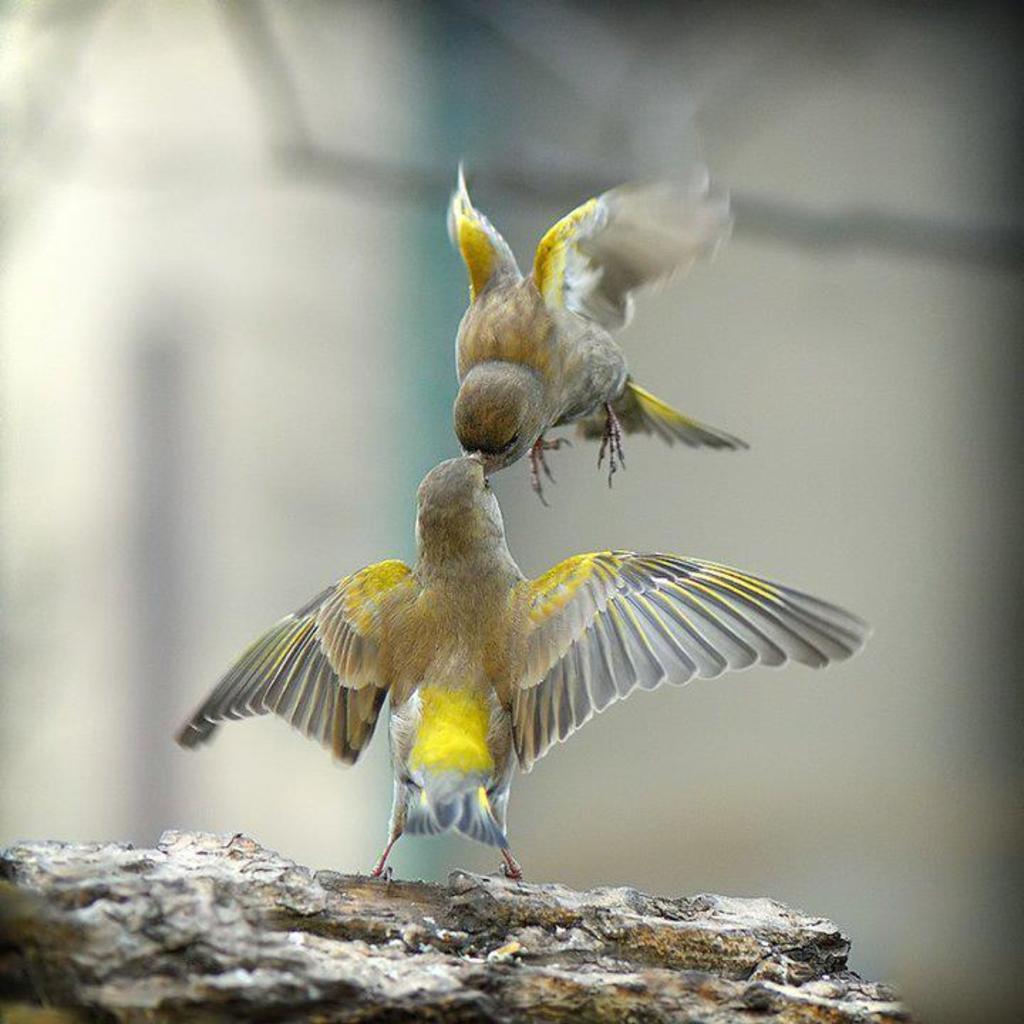In one or two sentences, can you explain what this image depicts? In this picture I can see there are two birds, one is flying and the other one is on the rock. The backdrop of the image is blurred. 